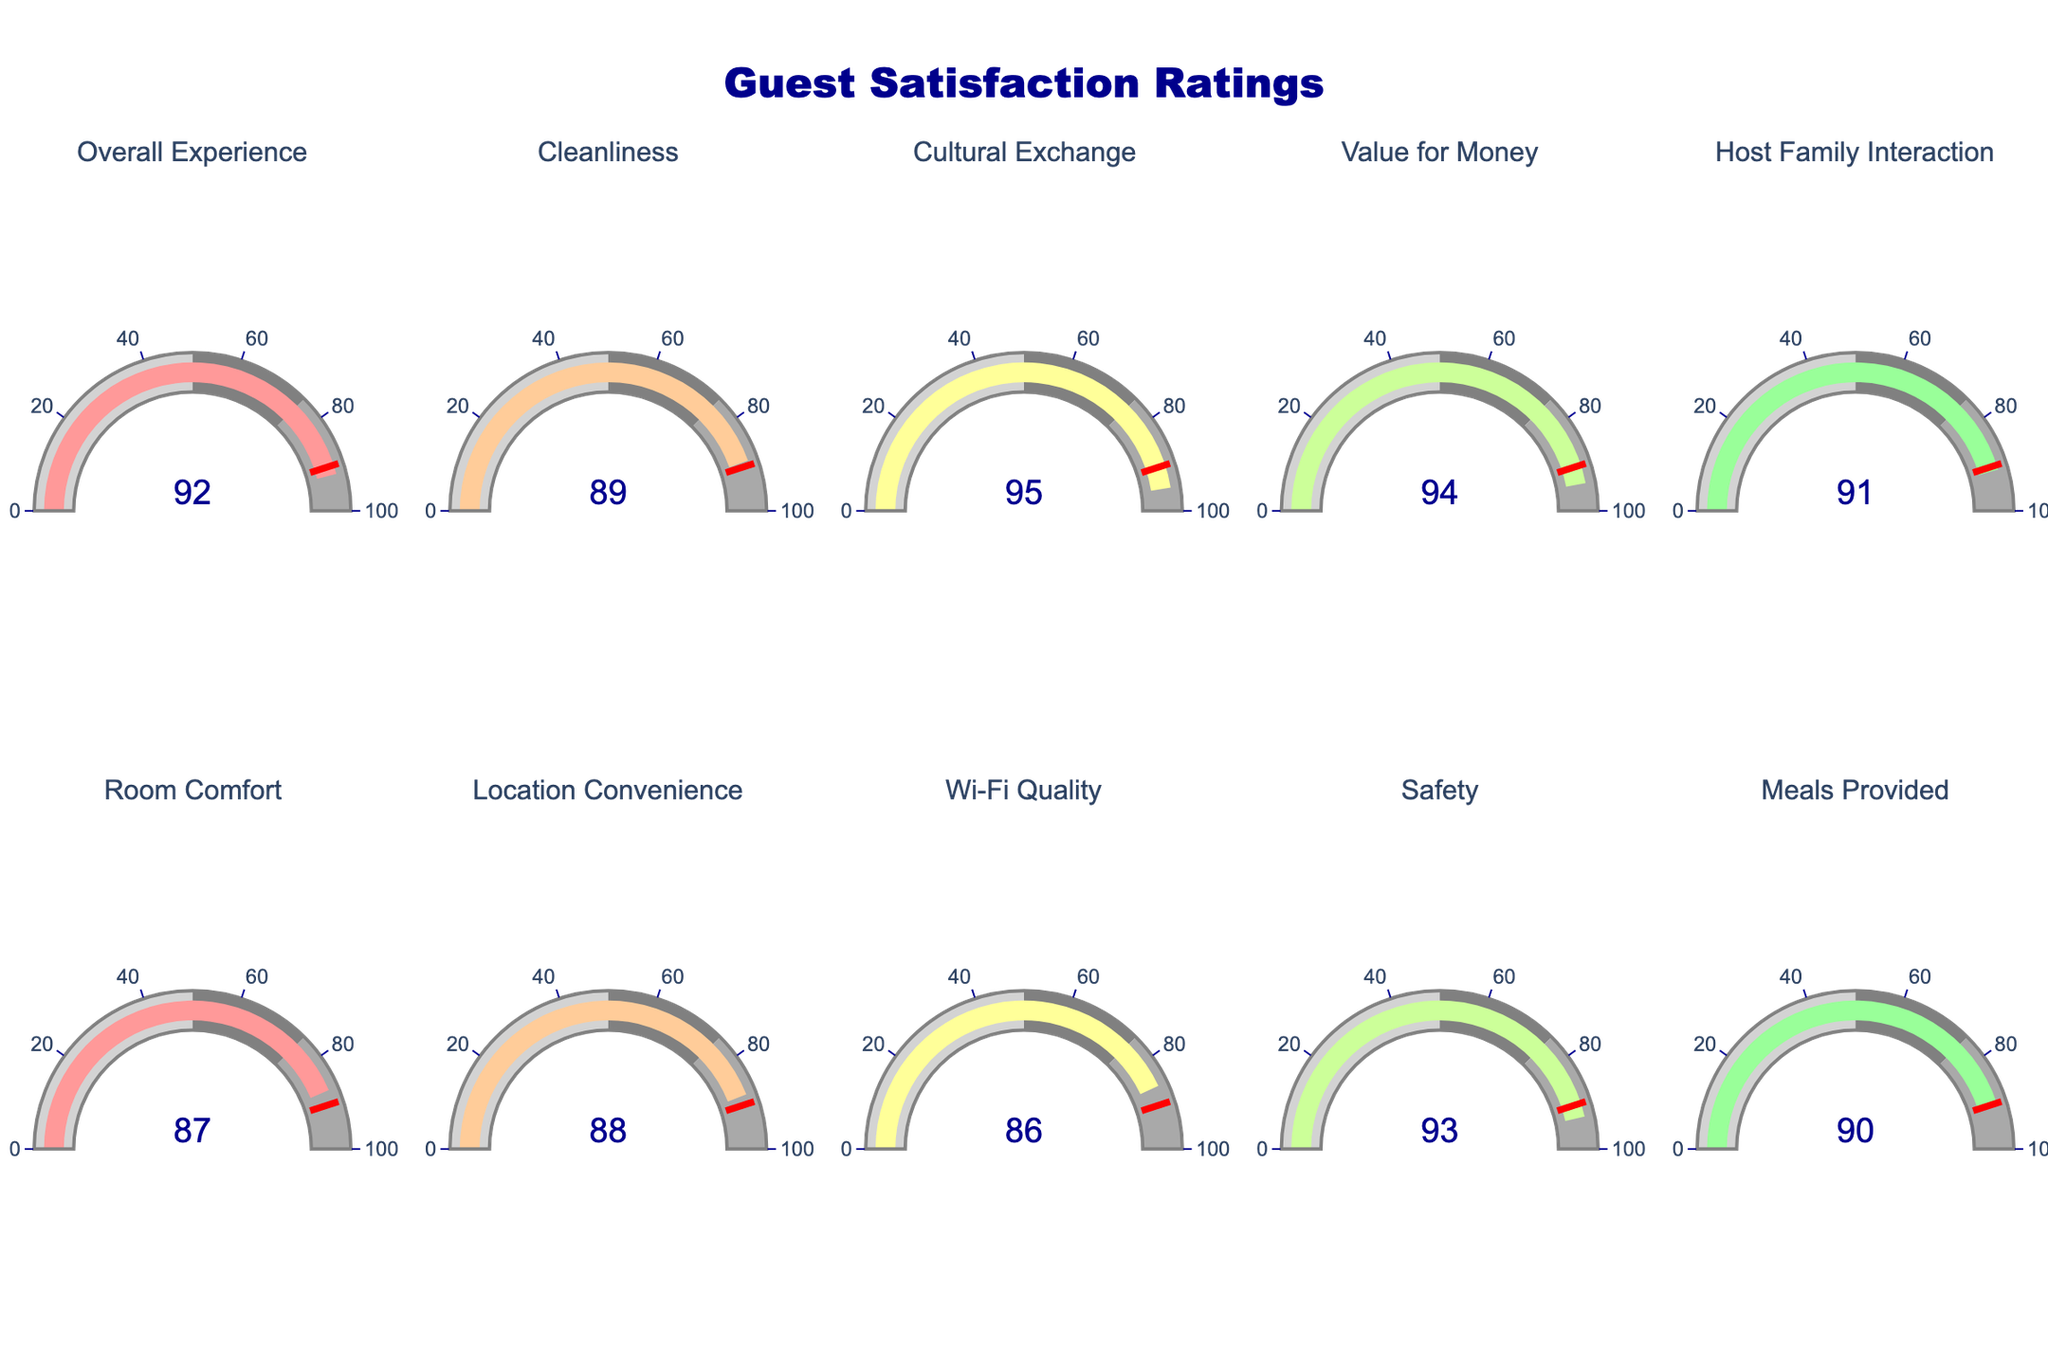What category received the highest satisfaction rating? To find the highest satisfaction rating, look for the gauge displaying the largest number. Here, the highest rating is in the "Cultural Exchange" category with a rating of 95.
Answer: Cultural Exchange What is the overall satisfaction rating for "Room Comfort"? Locate the "Room Comfort" gauge to see its rating. The satisfaction rating is 87.
Answer: 87 Which category has a satisfaction rating of 86? Locate the gauge chart that displays the number 86. The category with this rating is "Wi-Fi Quality."
Answer: Wi-Fi Quality What is the average satisfaction rating of "Host Family Interaction" and "Meals Provided"? Add the ratings for "Host Family Interaction" (91) and "Meals Provided" (90), then divide by 2 to find the average: (91+90)/2 = 90.5.
Answer: 90.5 How many categories have a satisfaction rating above 90? Count the gauges where the satisfaction rating is above 90. The categories are "Overall Experience" (92), "Cultural Exchange" (95), "Value for Money" (94), "Host Family Interaction" (91), and "Safety" (93), totaling 5.
Answer: 5 Which category has the lowest satisfaction rating? Look for the gauge displaying the smallest number. The lowest rating is in the "Wi-Fi Quality" category, with a rating of 86.
Answer: Wi-Fi Quality How much higher is the "Safety" satisfaction rating than the "Wi-Fi Quality" rating? Subtract the "Wi-Fi Quality" rating (86) from the "Safety" rating (93): 93 - 86 = 7.
Answer: 7 What is the difference between the highest and lowest satisfaction ratings? Subtract the lowest rating (86) from the highest rating (95): 95 - 86 = 9.
Answer: 9 Are there more categories with ratings below or above 90? Count gauges with ratings below 90 and those above 90. Below 90: Cleanliness (89), Room Comfort (87), Location Convenience (88), Wi-Fi Quality (86), Meals Provided (90). Above 90: Overall Experience (92), Cultural Exchange (95), Value for Money (94), Host Family Interaction (91), Safety (93). Both counts are equal at 5 each.
Answer: Equal 